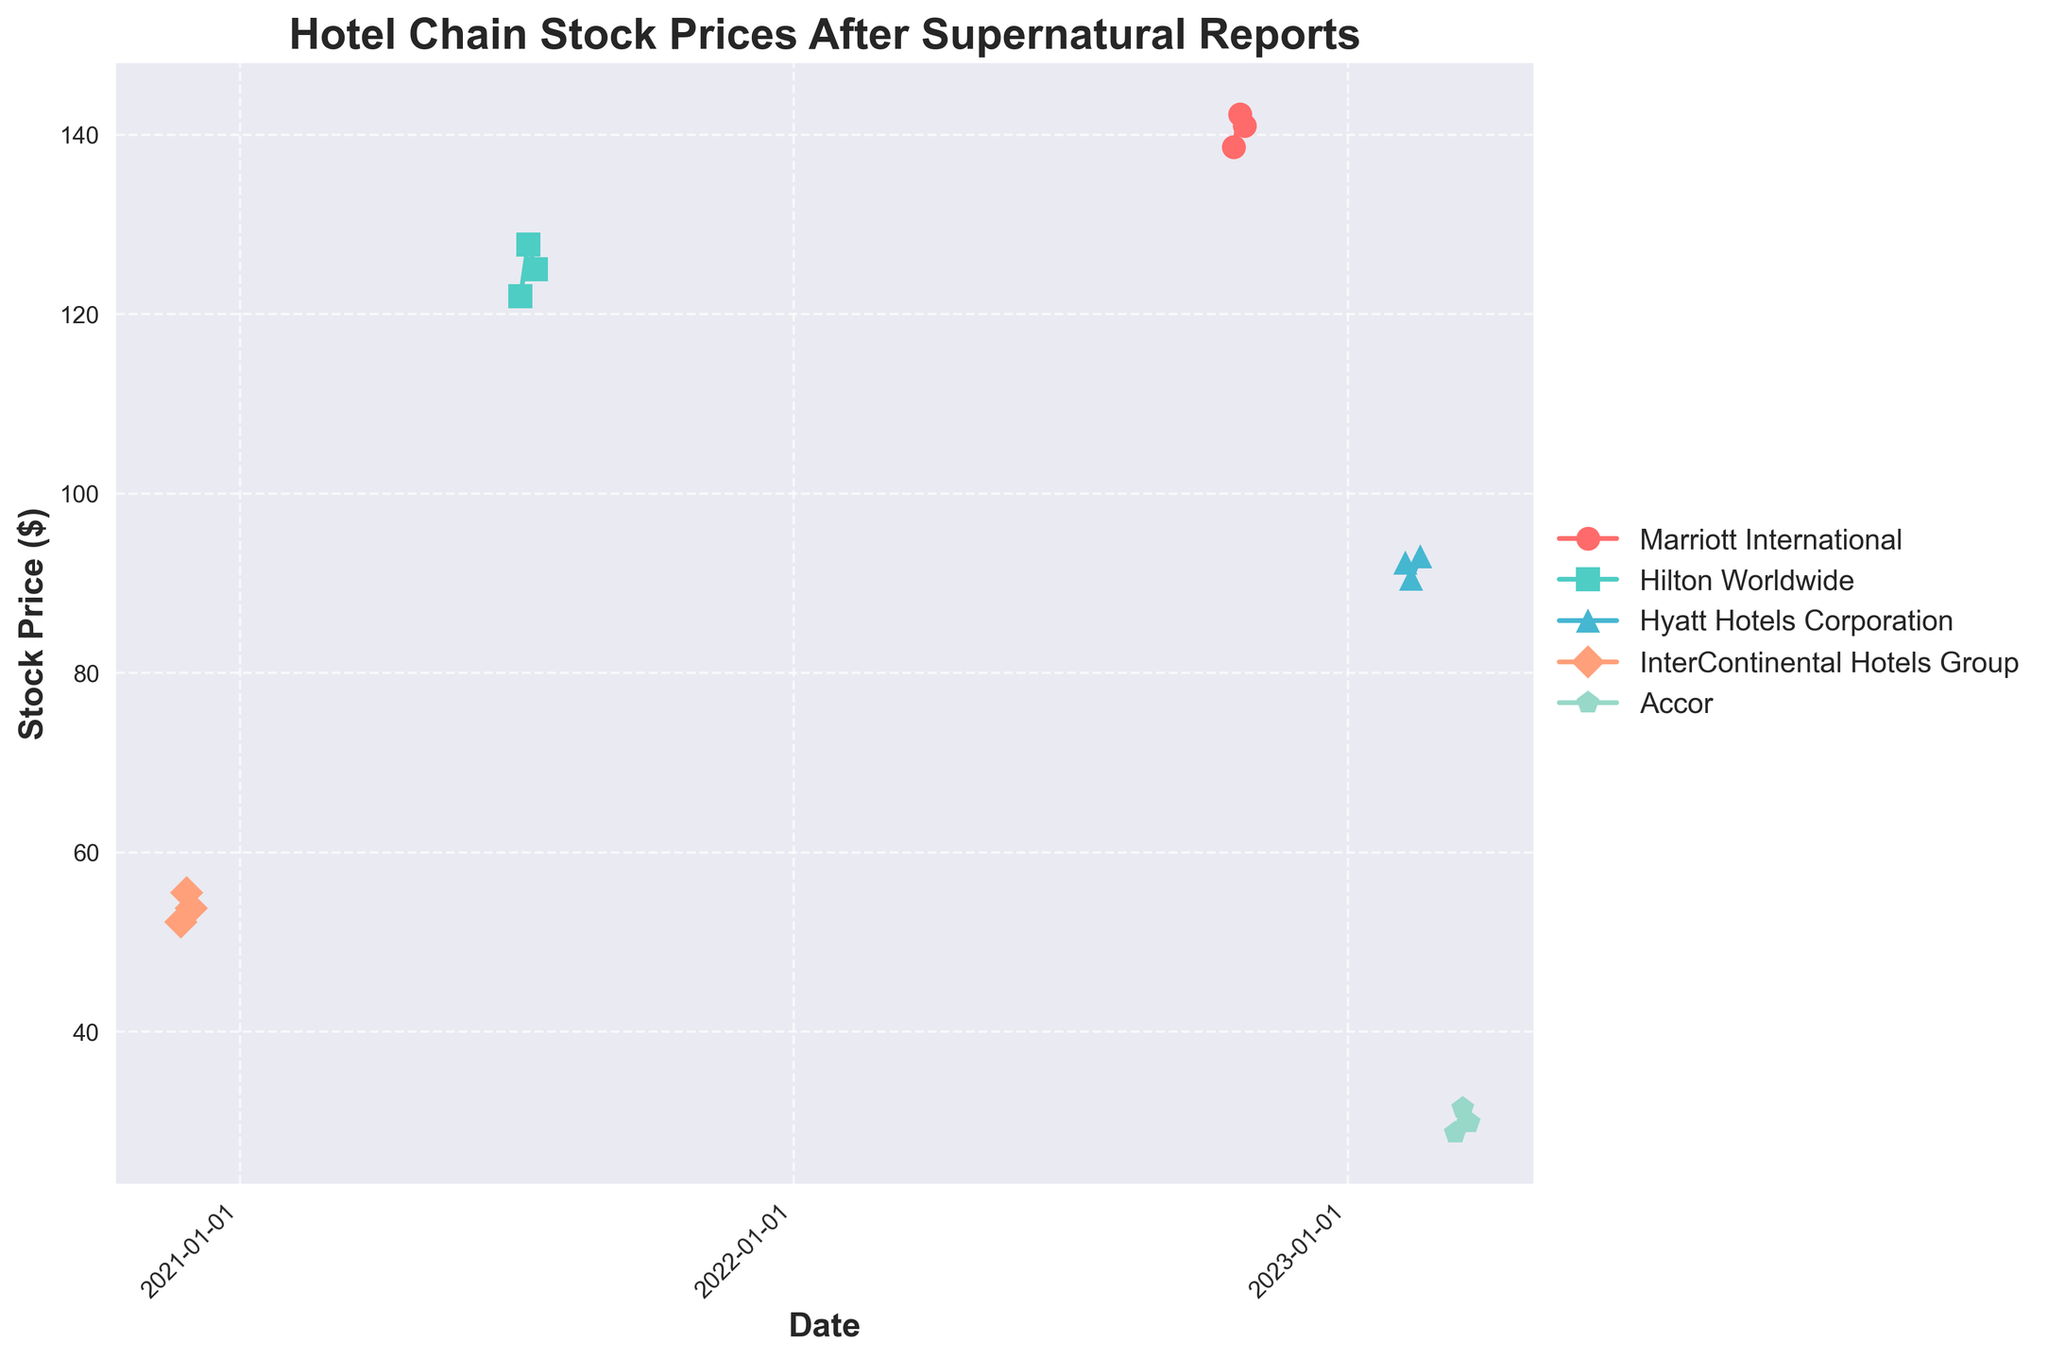What is the title of the plot? At the very top of the plot, there is a text which is the title. It reads "Hotel Chain Stock Prices After Supernatural Reports."
Answer: Hotel Chain Stock Prices After Supernatural Reports What date range is used for the data in the plot? By looking at the X-axis and the major date ticks marked, it covers data from November 2020 to March 2023.
Answer: November 2020 to March 2023 Which hotel chain has the highest stock price on any given date in the plot? By identifying the highest point on the Y-axis and cross-referencing the plotted data points, Marriott International has the highest stock price at $142.30 on October 22, 2022.
Answer: Marriott International What visual markers are used to represent Accor's data points? The legend indicates that Accor is represented with pentagon ('p') markers.
Answer: Pentagon markers How did the stock price of Hilton Worldwide change from July 5, 2021, to July 15, 2021? Click on data points representing Hilton Worldwide:
- July 5, 2021: $122.00
- July 15, 2021: $125.00
First, locate both dates on the X-axis and check corresponding Y-axis values. The change is the difference between these values, $125.00 - $122.00 = $3.00.
Answer: $3.00 increase Which hotel chain showed an increase in stock price after introducing themed events? By looking at the specified dates and event descriptions, InterContinental Hotels Group's stock price increased from $52.25 on November 23, 2020, to $55.50 on November 27, 2020, after introducing themed events.
Answer: InterContinental Hotels Group What is the average stock price of their data points for Hyatt Hotels Corporation? Identify all data points for Hyatt Hotels Corporation:
- $92.30, $90.50, $93.00
Sum them up: $92.30 + $90.50 + $93.00 = $275.80
Divide by the number of data points: $275.80 / 3 ≈ $91.93
Answer: $91.93 Which hotel chain experienced a decrease in stock price after announcing an official investigation? Refer to date and events: Hyatt Hotels Corporation announced an official investigation on February 12, 2023. Its stock price decreased from $92.30 to $90.50.
Answer: Hyatt Hotels Corporation Which hotel chain had the most stable stock price over the entire date range? Evaluating the lines with the least fluctuation, Marriott International's line shows consistency with slight increases and decreases, implying stability.
Answer: Marriott International 